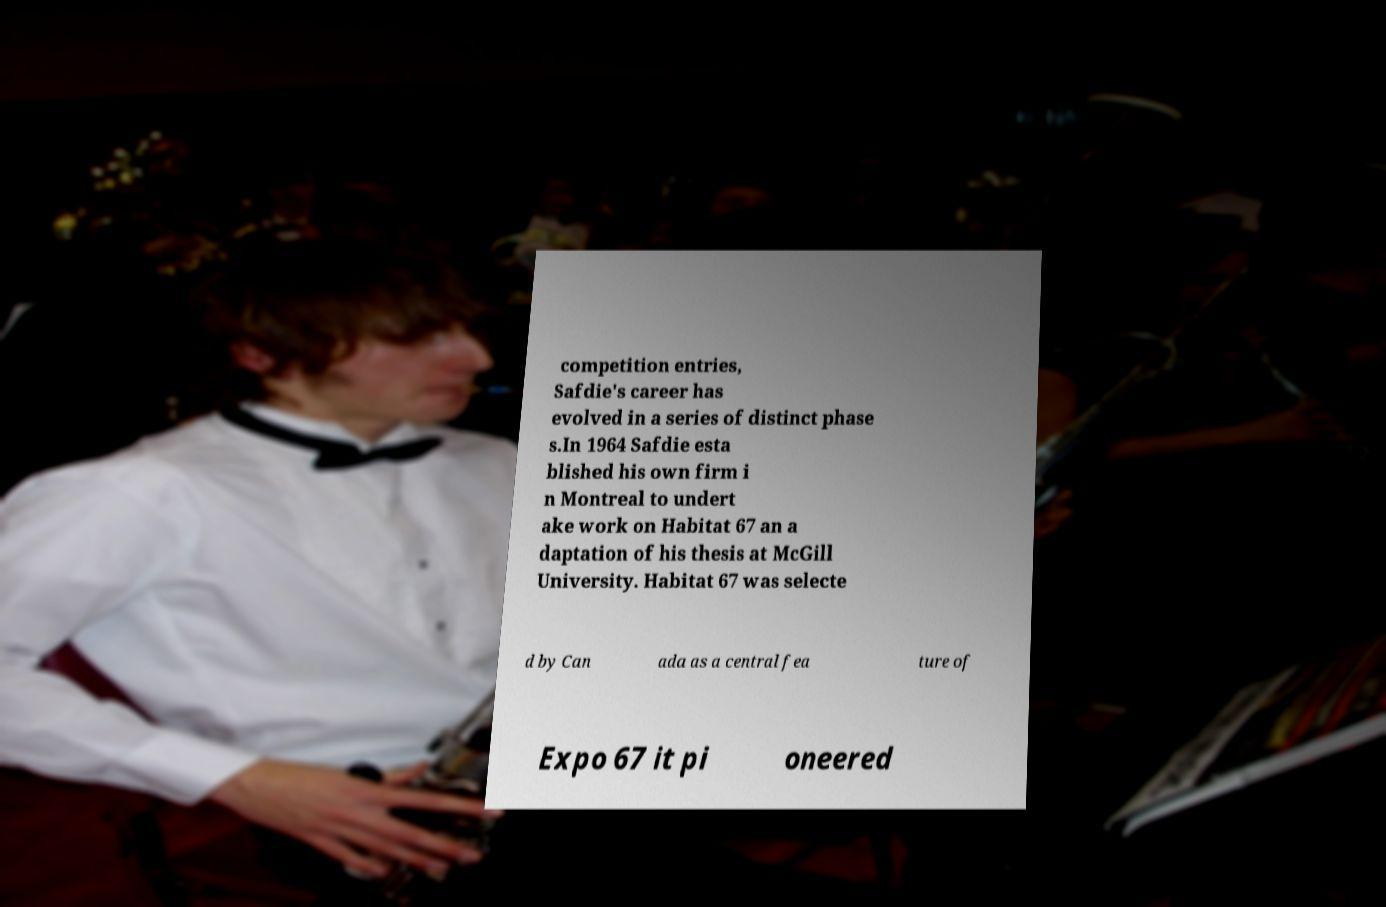Could you assist in decoding the text presented in this image and type it out clearly? competition entries, Safdie's career has evolved in a series of distinct phase s.In 1964 Safdie esta blished his own firm i n Montreal to undert ake work on Habitat 67 an a daptation of his thesis at McGill University. Habitat 67 was selecte d by Can ada as a central fea ture of Expo 67 it pi oneered 